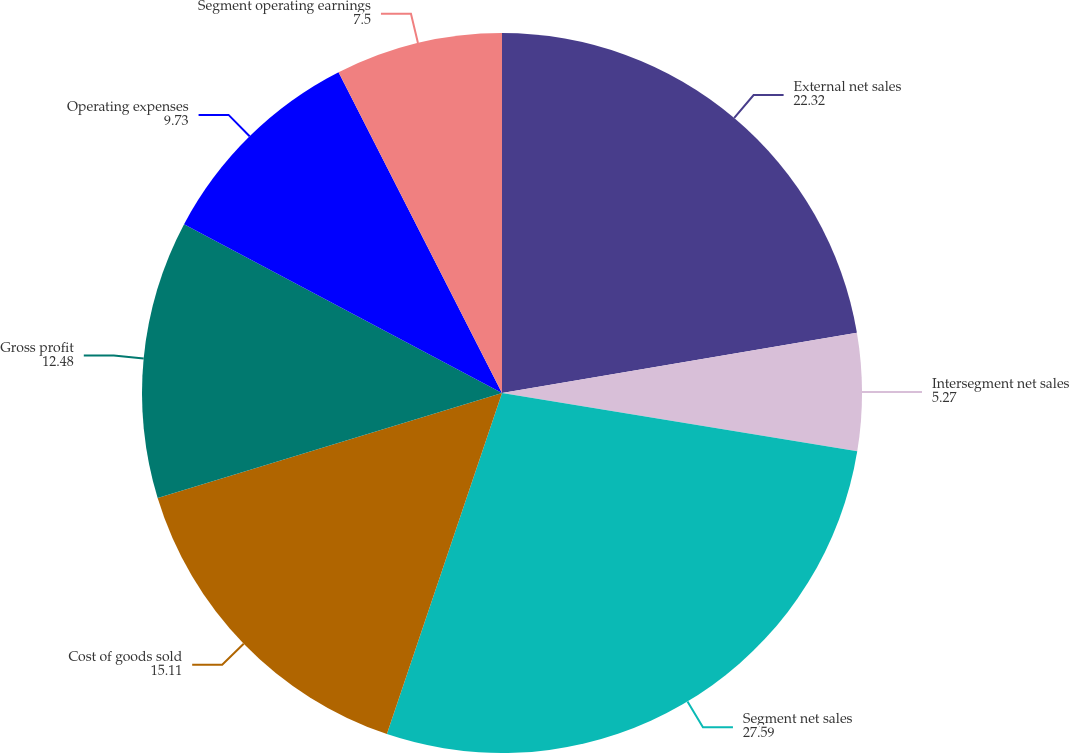Convert chart to OTSL. <chart><loc_0><loc_0><loc_500><loc_500><pie_chart><fcel>External net sales<fcel>Intersegment net sales<fcel>Segment net sales<fcel>Cost of goods sold<fcel>Gross profit<fcel>Operating expenses<fcel>Segment operating earnings<nl><fcel>22.32%<fcel>5.27%<fcel>27.59%<fcel>15.11%<fcel>12.48%<fcel>9.73%<fcel>7.5%<nl></chart> 